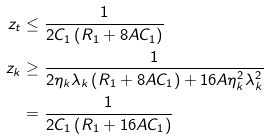<formula> <loc_0><loc_0><loc_500><loc_500>z _ { t } & \leq \frac { 1 } { 2 C _ { 1 } \left ( R _ { 1 } + 8 A C _ { 1 } \right ) } \\ z _ { k } & \geq \frac { 1 } { 2 \eta _ { k } \lambda _ { k } \left ( R _ { 1 } + 8 A C _ { 1 } \right ) + 1 6 A \eta _ { k } ^ { 2 } \lambda _ { k } ^ { 2 } } \\ & = \frac { 1 } { 2 C _ { 1 } \left ( R _ { 1 } + 1 6 A C _ { 1 } \right ) }</formula> 